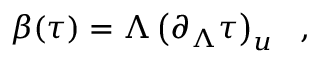<formula> <loc_0><loc_0><loc_500><loc_500>\beta ( \tau ) = \Lambda \left ( \partial _ { \Lambda } \tau \right ) _ { u } \ \ ,</formula> 